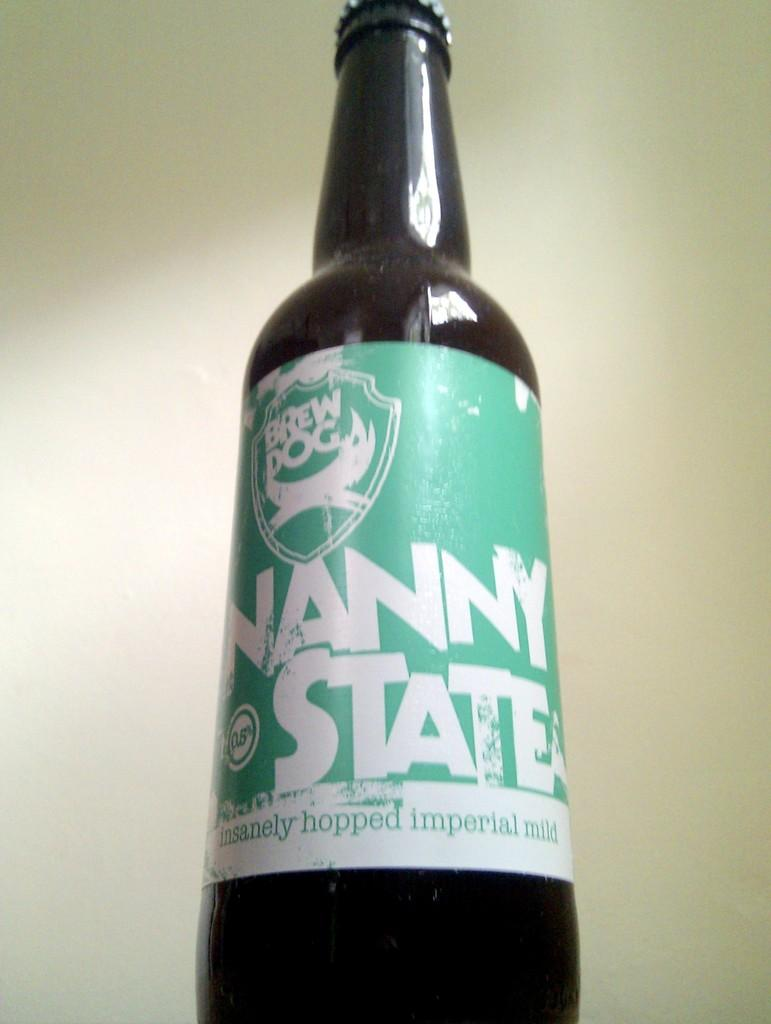<image>
Offer a succinct explanation of the picture presented. A beer bottle with a label that says Nanny State. 